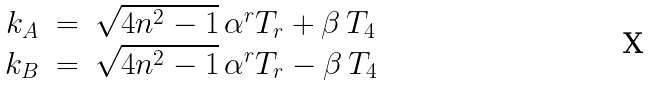Convert formula to latex. <formula><loc_0><loc_0><loc_500><loc_500>\begin{array} { r c l } { { k _ { A } } } & { = } & { { \sqrt { 4 n ^ { 2 } - 1 } \, \alpha ^ { r } T _ { r } + \beta \, T _ { 4 } } } \\ { { k _ { B } } } & { = } & { { \sqrt { 4 n ^ { 2 } - 1 } \, \alpha ^ { r } T _ { r } - \beta \, T _ { 4 } } } \end{array}</formula> 